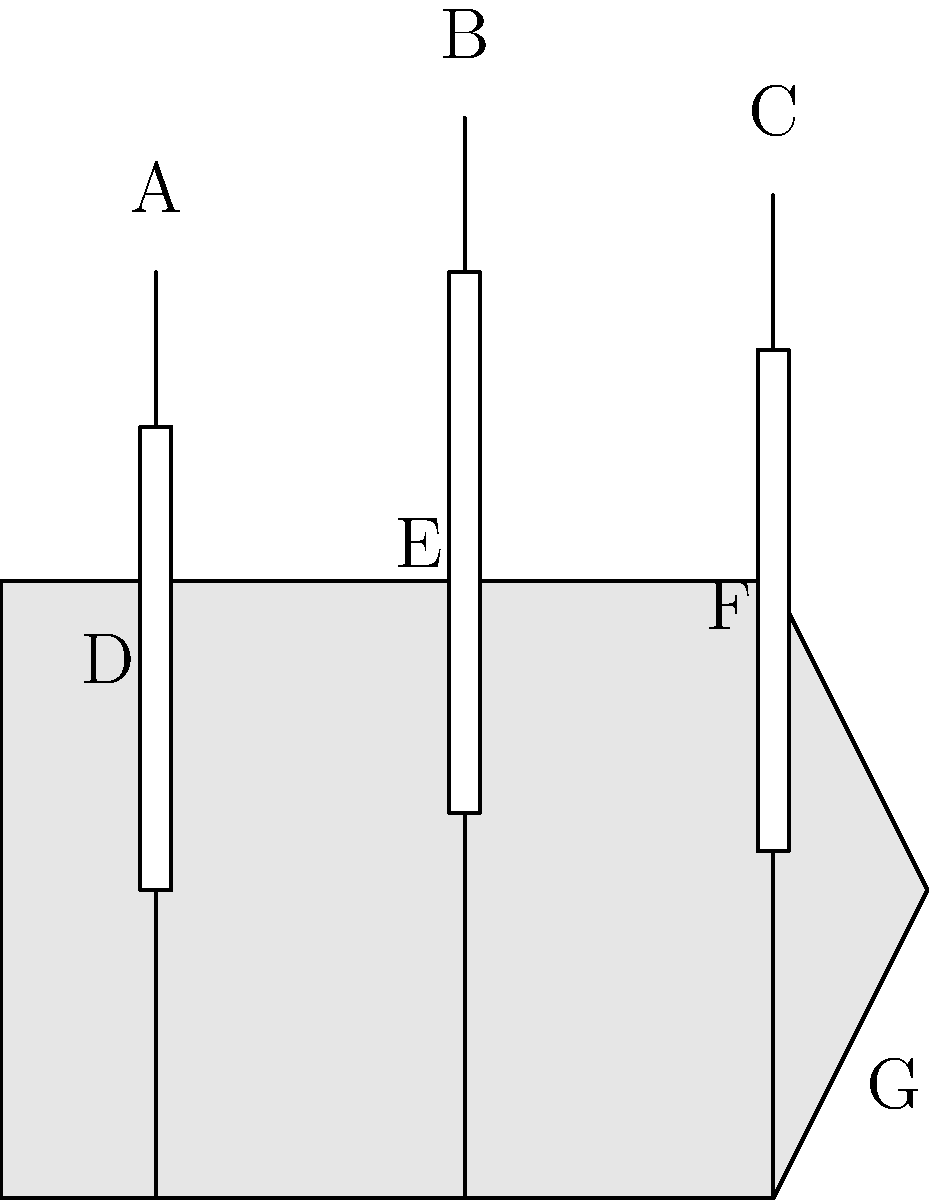In many historical fiction novels set in the Age of Sail, ships are described with varying degrees of accuracy. Based on the labeled diagram of a typical three-masted sailing ship, which of the following statements is most likely to be historically accurate in a well-researched maritime novel?

a) The sail marked 'D' would be referred to as the "mainsail" by the crew.
b) The mast labeled 'B' would typically be called the "mizzen mast" by sailors.
c) The part of the ship marked 'G' would commonly be known as the "stern" in nautical terminology.
d) The sail labeled 'F' would generally be called the "mizzen sail" by experienced seamen. To answer this question accurately, we need to analyze each component of the ship and its correct nautical terminology:

1. Mast identification:
   A - Foremast (front)
   B - Mainmast (middle, typically the tallest)
   C - Mizzenmast (rear)

2. Sail identification:
   D - Foresail (on the foremast)
   E - Mainsail (on the mainmast)
   F - Mizzen sail (on the mizzenmast)

3. Ship parts:
   G - This part of the ship is the bow (front), not the stern (rear)

Now, let's evaluate each option:

a) Incorrect. The sail marked 'D' is the foresail, not the mainsail.
b) Incorrect. The mast labeled 'B' is the mainmast, not the mizzen mast.
c) Incorrect. The part marked 'G' is the bow, not the stern.
d) Correct. The sail labeled 'F' is indeed the mizzen sail, attached to the mizzenmast.

In a well-researched maritime novel, the author would be expected to use correct nautical terminology. Therefore, option d) is the most likely to be historically accurate.
Answer: d) The sail labeled 'F' would generally be called the "mizzen sail" by experienced seamen. 